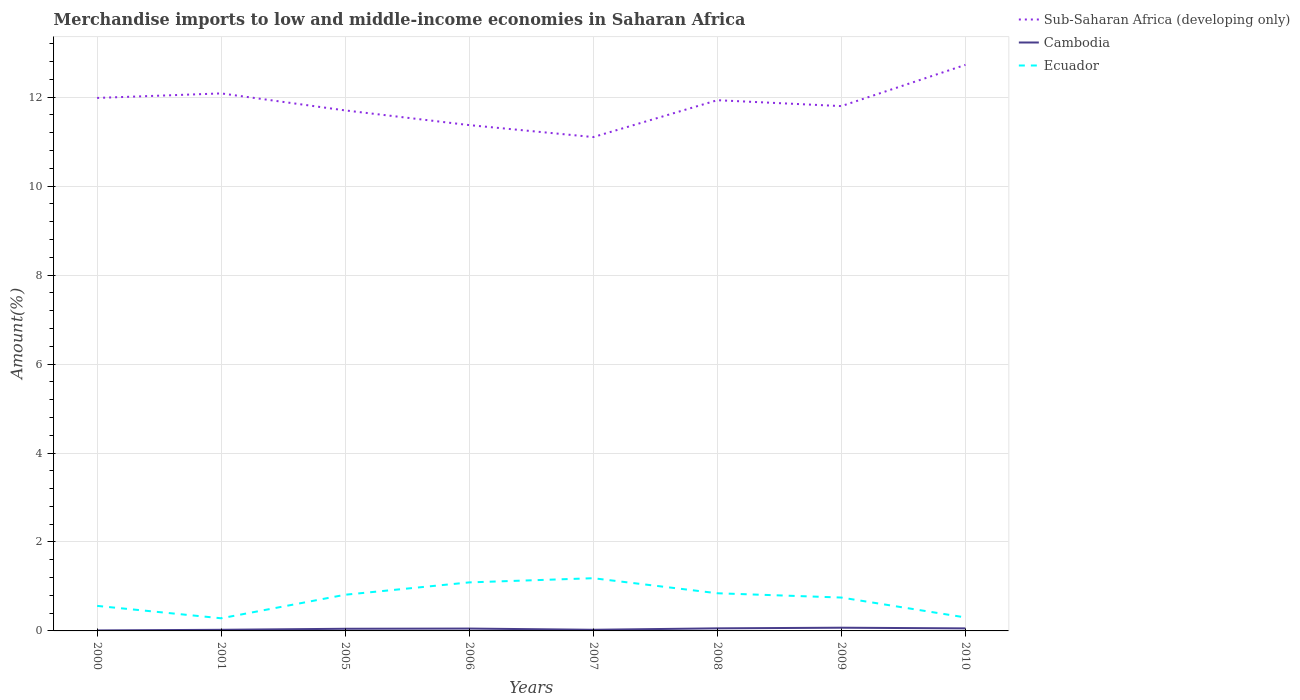Is the number of lines equal to the number of legend labels?
Provide a succinct answer. Yes. Across all years, what is the maximum percentage of amount earned from merchandise imports in Cambodia?
Offer a terse response. 0.01. In which year was the percentage of amount earned from merchandise imports in Cambodia maximum?
Ensure brevity in your answer.  2000. What is the total percentage of amount earned from merchandise imports in Cambodia in the graph?
Provide a succinct answer. -0.01. What is the difference between the highest and the second highest percentage of amount earned from merchandise imports in Sub-Saharan Africa (developing only)?
Keep it short and to the point. 1.62. Is the percentage of amount earned from merchandise imports in Sub-Saharan Africa (developing only) strictly greater than the percentage of amount earned from merchandise imports in Ecuador over the years?
Offer a terse response. No. What is the difference between two consecutive major ticks on the Y-axis?
Your answer should be very brief. 2. Are the values on the major ticks of Y-axis written in scientific E-notation?
Provide a short and direct response. No. Does the graph contain grids?
Ensure brevity in your answer.  Yes. How are the legend labels stacked?
Provide a succinct answer. Vertical. What is the title of the graph?
Offer a very short reply. Merchandise imports to low and middle-income economies in Saharan Africa. What is the label or title of the Y-axis?
Give a very brief answer. Amount(%). What is the Amount(%) in Sub-Saharan Africa (developing only) in 2000?
Your answer should be compact. 11.98. What is the Amount(%) of Cambodia in 2000?
Offer a very short reply. 0.01. What is the Amount(%) in Ecuador in 2000?
Your response must be concise. 0.56. What is the Amount(%) in Sub-Saharan Africa (developing only) in 2001?
Your answer should be very brief. 12.08. What is the Amount(%) of Cambodia in 2001?
Keep it short and to the point. 0.03. What is the Amount(%) in Ecuador in 2001?
Make the answer very short. 0.28. What is the Amount(%) of Sub-Saharan Africa (developing only) in 2005?
Make the answer very short. 11.7. What is the Amount(%) in Cambodia in 2005?
Offer a terse response. 0.05. What is the Amount(%) in Ecuador in 2005?
Give a very brief answer. 0.81. What is the Amount(%) in Sub-Saharan Africa (developing only) in 2006?
Make the answer very short. 11.37. What is the Amount(%) in Cambodia in 2006?
Provide a short and direct response. 0.05. What is the Amount(%) of Ecuador in 2006?
Your answer should be very brief. 1.09. What is the Amount(%) of Sub-Saharan Africa (developing only) in 2007?
Offer a very short reply. 11.1. What is the Amount(%) in Cambodia in 2007?
Keep it short and to the point. 0.03. What is the Amount(%) of Ecuador in 2007?
Your response must be concise. 1.19. What is the Amount(%) of Sub-Saharan Africa (developing only) in 2008?
Your answer should be compact. 11.93. What is the Amount(%) of Cambodia in 2008?
Make the answer very short. 0.06. What is the Amount(%) of Ecuador in 2008?
Keep it short and to the point. 0.85. What is the Amount(%) of Sub-Saharan Africa (developing only) in 2009?
Provide a short and direct response. 11.8. What is the Amount(%) of Cambodia in 2009?
Keep it short and to the point. 0.07. What is the Amount(%) in Ecuador in 2009?
Provide a short and direct response. 0.75. What is the Amount(%) in Sub-Saharan Africa (developing only) in 2010?
Make the answer very short. 12.73. What is the Amount(%) in Cambodia in 2010?
Offer a terse response. 0.06. What is the Amount(%) of Ecuador in 2010?
Keep it short and to the point. 0.3. Across all years, what is the maximum Amount(%) in Sub-Saharan Africa (developing only)?
Your answer should be compact. 12.73. Across all years, what is the maximum Amount(%) of Cambodia?
Make the answer very short. 0.07. Across all years, what is the maximum Amount(%) in Ecuador?
Give a very brief answer. 1.19. Across all years, what is the minimum Amount(%) of Sub-Saharan Africa (developing only)?
Give a very brief answer. 11.1. Across all years, what is the minimum Amount(%) of Cambodia?
Your answer should be compact. 0.01. Across all years, what is the minimum Amount(%) in Ecuador?
Your answer should be very brief. 0.28. What is the total Amount(%) in Sub-Saharan Africa (developing only) in the graph?
Ensure brevity in your answer.  94.7. What is the total Amount(%) in Cambodia in the graph?
Ensure brevity in your answer.  0.35. What is the total Amount(%) in Ecuador in the graph?
Offer a very short reply. 5.84. What is the difference between the Amount(%) of Sub-Saharan Africa (developing only) in 2000 and that in 2001?
Offer a terse response. -0.1. What is the difference between the Amount(%) in Cambodia in 2000 and that in 2001?
Give a very brief answer. -0.01. What is the difference between the Amount(%) in Ecuador in 2000 and that in 2001?
Provide a short and direct response. 0.28. What is the difference between the Amount(%) of Sub-Saharan Africa (developing only) in 2000 and that in 2005?
Your answer should be very brief. 0.28. What is the difference between the Amount(%) of Cambodia in 2000 and that in 2005?
Make the answer very short. -0.04. What is the difference between the Amount(%) of Ecuador in 2000 and that in 2005?
Keep it short and to the point. -0.25. What is the difference between the Amount(%) in Sub-Saharan Africa (developing only) in 2000 and that in 2006?
Provide a short and direct response. 0.61. What is the difference between the Amount(%) in Cambodia in 2000 and that in 2006?
Give a very brief answer. -0.04. What is the difference between the Amount(%) of Ecuador in 2000 and that in 2006?
Keep it short and to the point. -0.53. What is the difference between the Amount(%) in Sub-Saharan Africa (developing only) in 2000 and that in 2007?
Provide a succinct answer. 0.88. What is the difference between the Amount(%) of Cambodia in 2000 and that in 2007?
Keep it short and to the point. -0.01. What is the difference between the Amount(%) of Ecuador in 2000 and that in 2007?
Keep it short and to the point. -0.62. What is the difference between the Amount(%) in Sub-Saharan Africa (developing only) in 2000 and that in 2008?
Provide a short and direct response. 0.05. What is the difference between the Amount(%) in Cambodia in 2000 and that in 2008?
Offer a very short reply. -0.05. What is the difference between the Amount(%) in Ecuador in 2000 and that in 2008?
Your answer should be compact. -0.28. What is the difference between the Amount(%) in Sub-Saharan Africa (developing only) in 2000 and that in 2009?
Your answer should be very brief. 0.18. What is the difference between the Amount(%) of Cambodia in 2000 and that in 2009?
Provide a short and direct response. -0.06. What is the difference between the Amount(%) in Ecuador in 2000 and that in 2009?
Offer a very short reply. -0.19. What is the difference between the Amount(%) in Sub-Saharan Africa (developing only) in 2000 and that in 2010?
Ensure brevity in your answer.  -0.74. What is the difference between the Amount(%) in Cambodia in 2000 and that in 2010?
Keep it short and to the point. -0.05. What is the difference between the Amount(%) of Ecuador in 2000 and that in 2010?
Offer a very short reply. 0.26. What is the difference between the Amount(%) of Sub-Saharan Africa (developing only) in 2001 and that in 2005?
Provide a short and direct response. 0.38. What is the difference between the Amount(%) of Cambodia in 2001 and that in 2005?
Ensure brevity in your answer.  -0.02. What is the difference between the Amount(%) of Ecuador in 2001 and that in 2005?
Your response must be concise. -0.53. What is the difference between the Amount(%) in Sub-Saharan Africa (developing only) in 2001 and that in 2006?
Your answer should be compact. 0.71. What is the difference between the Amount(%) of Cambodia in 2001 and that in 2006?
Offer a terse response. -0.03. What is the difference between the Amount(%) in Ecuador in 2001 and that in 2006?
Your response must be concise. -0.81. What is the difference between the Amount(%) in Sub-Saharan Africa (developing only) in 2001 and that in 2007?
Give a very brief answer. 0.98. What is the difference between the Amount(%) in Cambodia in 2001 and that in 2007?
Your answer should be compact. -0. What is the difference between the Amount(%) of Ecuador in 2001 and that in 2007?
Your answer should be very brief. -0.9. What is the difference between the Amount(%) in Sub-Saharan Africa (developing only) in 2001 and that in 2008?
Your answer should be very brief. 0.15. What is the difference between the Amount(%) in Cambodia in 2001 and that in 2008?
Provide a short and direct response. -0.03. What is the difference between the Amount(%) in Ecuador in 2001 and that in 2008?
Your response must be concise. -0.56. What is the difference between the Amount(%) of Sub-Saharan Africa (developing only) in 2001 and that in 2009?
Give a very brief answer. 0.29. What is the difference between the Amount(%) of Cambodia in 2001 and that in 2009?
Give a very brief answer. -0.05. What is the difference between the Amount(%) of Ecuador in 2001 and that in 2009?
Offer a terse response. -0.47. What is the difference between the Amount(%) in Sub-Saharan Africa (developing only) in 2001 and that in 2010?
Provide a short and direct response. -0.64. What is the difference between the Amount(%) of Cambodia in 2001 and that in 2010?
Keep it short and to the point. -0.03. What is the difference between the Amount(%) in Ecuador in 2001 and that in 2010?
Your response must be concise. -0.02. What is the difference between the Amount(%) in Sub-Saharan Africa (developing only) in 2005 and that in 2006?
Your answer should be compact. 0.33. What is the difference between the Amount(%) of Cambodia in 2005 and that in 2006?
Provide a succinct answer. -0. What is the difference between the Amount(%) of Ecuador in 2005 and that in 2006?
Keep it short and to the point. -0.28. What is the difference between the Amount(%) in Sub-Saharan Africa (developing only) in 2005 and that in 2007?
Provide a succinct answer. 0.6. What is the difference between the Amount(%) in Cambodia in 2005 and that in 2007?
Give a very brief answer. 0.02. What is the difference between the Amount(%) of Ecuador in 2005 and that in 2007?
Offer a terse response. -0.37. What is the difference between the Amount(%) of Sub-Saharan Africa (developing only) in 2005 and that in 2008?
Your response must be concise. -0.23. What is the difference between the Amount(%) in Cambodia in 2005 and that in 2008?
Ensure brevity in your answer.  -0.01. What is the difference between the Amount(%) of Ecuador in 2005 and that in 2008?
Offer a very short reply. -0.03. What is the difference between the Amount(%) in Sub-Saharan Africa (developing only) in 2005 and that in 2009?
Offer a very short reply. -0.1. What is the difference between the Amount(%) in Cambodia in 2005 and that in 2009?
Your response must be concise. -0.02. What is the difference between the Amount(%) in Ecuador in 2005 and that in 2009?
Provide a succinct answer. 0.06. What is the difference between the Amount(%) of Sub-Saharan Africa (developing only) in 2005 and that in 2010?
Provide a succinct answer. -1.02. What is the difference between the Amount(%) of Cambodia in 2005 and that in 2010?
Your answer should be compact. -0.01. What is the difference between the Amount(%) in Ecuador in 2005 and that in 2010?
Your response must be concise. 0.51. What is the difference between the Amount(%) in Sub-Saharan Africa (developing only) in 2006 and that in 2007?
Give a very brief answer. 0.27. What is the difference between the Amount(%) of Cambodia in 2006 and that in 2007?
Give a very brief answer. 0.03. What is the difference between the Amount(%) of Ecuador in 2006 and that in 2007?
Keep it short and to the point. -0.09. What is the difference between the Amount(%) in Sub-Saharan Africa (developing only) in 2006 and that in 2008?
Your response must be concise. -0.56. What is the difference between the Amount(%) of Cambodia in 2006 and that in 2008?
Offer a very short reply. -0. What is the difference between the Amount(%) in Ecuador in 2006 and that in 2008?
Your answer should be very brief. 0.24. What is the difference between the Amount(%) of Sub-Saharan Africa (developing only) in 2006 and that in 2009?
Your response must be concise. -0.43. What is the difference between the Amount(%) of Cambodia in 2006 and that in 2009?
Offer a very short reply. -0.02. What is the difference between the Amount(%) of Ecuador in 2006 and that in 2009?
Your answer should be very brief. 0.34. What is the difference between the Amount(%) in Sub-Saharan Africa (developing only) in 2006 and that in 2010?
Offer a terse response. -1.35. What is the difference between the Amount(%) of Cambodia in 2006 and that in 2010?
Provide a succinct answer. -0. What is the difference between the Amount(%) in Ecuador in 2006 and that in 2010?
Offer a terse response. 0.79. What is the difference between the Amount(%) in Sub-Saharan Africa (developing only) in 2007 and that in 2008?
Make the answer very short. -0.83. What is the difference between the Amount(%) in Cambodia in 2007 and that in 2008?
Make the answer very short. -0.03. What is the difference between the Amount(%) in Ecuador in 2007 and that in 2008?
Provide a short and direct response. 0.34. What is the difference between the Amount(%) of Sub-Saharan Africa (developing only) in 2007 and that in 2009?
Your answer should be very brief. -0.7. What is the difference between the Amount(%) of Cambodia in 2007 and that in 2009?
Your answer should be compact. -0.05. What is the difference between the Amount(%) in Ecuador in 2007 and that in 2009?
Keep it short and to the point. 0.43. What is the difference between the Amount(%) in Sub-Saharan Africa (developing only) in 2007 and that in 2010?
Offer a terse response. -1.62. What is the difference between the Amount(%) of Cambodia in 2007 and that in 2010?
Offer a very short reply. -0.03. What is the difference between the Amount(%) in Ecuador in 2007 and that in 2010?
Provide a succinct answer. 0.88. What is the difference between the Amount(%) in Sub-Saharan Africa (developing only) in 2008 and that in 2009?
Ensure brevity in your answer.  0.13. What is the difference between the Amount(%) in Cambodia in 2008 and that in 2009?
Give a very brief answer. -0.01. What is the difference between the Amount(%) in Ecuador in 2008 and that in 2009?
Give a very brief answer. 0.1. What is the difference between the Amount(%) of Sub-Saharan Africa (developing only) in 2008 and that in 2010?
Provide a succinct answer. -0.79. What is the difference between the Amount(%) of Cambodia in 2008 and that in 2010?
Your response must be concise. 0. What is the difference between the Amount(%) of Ecuador in 2008 and that in 2010?
Offer a terse response. 0.54. What is the difference between the Amount(%) of Sub-Saharan Africa (developing only) in 2009 and that in 2010?
Your answer should be very brief. -0.93. What is the difference between the Amount(%) of Cambodia in 2009 and that in 2010?
Provide a succinct answer. 0.02. What is the difference between the Amount(%) in Ecuador in 2009 and that in 2010?
Your response must be concise. 0.45. What is the difference between the Amount(%) in Sub-Saharan Africa (developing only) in 2000 and the Amount(%) in Cambodia in 2001?
Make the answer very short. 11.96. What is the difference between the Amount(%) in Sub-Saharan Africa (developing only) in 2000 and the Amount(%) in Ecuador in 2001?
Your answer should be very brief. 11.7. What is the difference between the Amount(%) in Cambodia in 2000 and the Amount(%) in Ecuador in 2001?
Offer a terse response. -0.27. What is the difference between the Amount(%) of Sub-Saharan Africa (developing only) in 2000 and the Amount(%) of Cambodia in 2005?
Offer a terse response. 11.93. What is the difference between the Amount(%) of Sub-Saharan Africa (developing only) in 2000 and the Amount(%) of Ecuador in 2005?
Provide a short and direct response. 11.17. What is the difference between the Amount(%) in Cambodia in 2000 and the Amount(%) in Ecuador in 2005?
Provide a short and direct response. -0.8. What is the difference between the Amount(%) in Sub-Saharan Africa (developing only) in 2000 and the Amount(%) in Cambodia in 2006?
Ensure brevity in your answer.  11.93. What is the difference between the Amount(%) of Sub-Saharan Africa (developing only) in 2000 and the Amount(%) of Ecuador in 2006?
Keep it short and to the point. 10.89. What is the difference between the Amount(%) of Cambodia in 2000 and the Amount(%) of Ecuador in 2006?
Your answer should be compact. -1.08. What is the difference between the Amount(%) in Sub-Saharan Africa (developing only) in 2000 and the Amount(%) in Cambodia in 2007?
Provide a short and direct response. 11.96. What is the difference between the Amount(%) in Sub-Saharan Africa (developing only) in 2000 and the Amount(%) in Ecuador in 2007?
Give a very brief answer. 10.8. What is the difference between the Amount(%) of Cambodia in 2000 and the Amount(%) of Ecuador in 2007?
Provide a short and direct response. -1.17. What is the difference between the Amount(%) in Sub-Saharan Africa (developing only) in 2000 and the Amount(%) in Cambodia in 2008?
Give a very brief answer. 11.92. What is the difference between the Amount(%) of Sub-Saharan Africa (developing only) in 2000 and the Amount(%) of Ecuador in 2008?
Provide a short and direct response. 11.14. What is the difference between the Amount(%) of Cambodia in 2000 and the Amount(%) of Ecuador in 2008?
Your response must be concise. -0.84. What is the difference between the Amount(%) of Sub-Saharan Africa (developing only) in 2000 and the Amount(%) of Cambodia in 2009?
Keep it short and to the point. 11.91. What is the difference between the Amount(%) of Sub-Saharan Africa (developing only) in 2000 and the Amount(%) of Ecuador in 2009?
Make the answer very short. 11.23. What is the difference between the Amount(%) of Cambodia in 2000 and the Amount(%) of Ecuador in 2009?
Offer a very short reply. -0.74. What is the difference between the Amount(%) of Sub-Saharan Africa (developing only) in 2000 and the Amount(%) of Cambodia in 2010?
Your response must be concise. 11.93. What is the difference between the Amount(%) in Sub-Saharan Africa (developing only) in 2000 and the Amount(%) in Ecuador in 2010?
Your answer should be compact. 11.68. What is the difference between the Amount(%) in Cambodia in 2000 and the Amount(%) in Ecuador in 2010?
Make the answer very short. -0.29. What is the difference between the Amount(%) of Sub-Saharan Africa (developing only) in 2001 and the Amount(%) of Cambodia in 2005?
Your answer should be very brief. 12.04. What is the difference between the Amount(%) in Sub-Saharan Africa (developing only) in 2001 and the Amount(%) in Ecuador in 2005?
Ensure brevity in your answer.  11.27. What is the difference between the Amount(%) in Cambodia in 2001 and the Amount(%) in Ecuador in 2005?
Ensure brevity in your answer.  -0.79. What is the difference between the Amount(%) in Sub-Saharan Africa (developing only) in 2001 and the Amount(%) in Cambodia in 2006?
Ensure brevity in your answer.  12.03. What is the difference between the Amount(%) of Sub-Saharan Africa (developing only) in 2001 and the Amount(%) of Ecuador in 2006?
Your response must be concise. 10.99. What is the difference between the Amount(%) of Cambodia in 2001 and the Amount(%) of Ecuador in 2006?
Your answer should be compact. -1.07. What is the difference between the Amount(%) in Sub-Saharan Africa (developing only) in 2001 and the Amount(%) in Cambodia in 2007?
Offer a terse response. 12.06. What is the difference between the Amount(%) of Sub-Saharan Africa (developing only) in 2001 and the Amount(%) of Ecuador in 2007?
Your answer should be compact. 10.9. What is the difference between the Amount(%) in Cambodia in 2001 and the Amount(%) in Ecuador in 2007?
Your answer should be very brief. -1.16. What is the difference between the Amount(%) of Sub-Saharan Africa (developing only) in 2001 and the Amount(%) of Cambodia in 2008?
Your response must be concise. 12.03. What is the difference between the Amount(%) of Sub-Saharan Africa (developing only) in 2001 and the Amount(%) of Ecuador in 2008?
Offer a terse response. 11.24. What is the difference between the Amount(%) in Cambodia in 2001 and the Amount(%) in Ecuador in 2008?
Your answer should be very brief. -0.82. What is the difference between the Amount(%) in Sub-Saharan Africa (developing only) in 2001 and the Amount(%) in Cambodia in 2009?
Give a very brief answer. 12.01. What is the difference between the Amount(%) of Sub-Saharan Africa (developing only) in 2001 and the Amount(%) of Ecuador in 2009?
Your answer should be very brief. 11.33. What is the difference between the Amount(%) in Cambodia in 2001 and the Amount(%) in Ecuador in 2009?
Keep it short and to the point. -0.73. What is the difference between the Amount(%) of Sub-Saharan Africa (developing only) in 2001 and the Amount(%) of Cambodia in 2010?
Offer a terse response. 12.03. What is the difference between the Amount(%) in Sub-Saharan Africa (developing only) in 2001 and the Amount(%) in Ecuador in 2010?
Keep it short and to the point. 11.78. What is the difference between the Amount(%) of Cambodia in 2001 and the Amount(%) of Ecuador in 2010?
Your answer should be very brief. -0.28. What is the difference between the Amount(%) in Sub-Saharan Africa (developing only) in 2005 and the Amount(%) in Cambodia in 2006?
Provide a short and direct response. 11.65. What is the difference between the Amount(%) of Sub-Saharan Africa (developing only) in 2005 and the Amount(%) of Ecuador in 2006?
Keep it short and to the point. 10.61. What is the difference between the Amount(%) in Cambodia in 2005 and the Amount(%) in Ecuador in 2006?
Your response must be concise. -1.04. What is the difference between the Amount(%) in Sub-Saharan Africa (developing only) in 2005 and the Amount(%) in Cambodia in 2007?
Your answer should be very brief. 11.68. What is the difference between the Amount(%) in Sub-Saharan Africa (developing only) in 2005 and the Amount(%) in Ecuador in 2007?
Provide a succinct answer. 10.52. What is the difference between the Amount(%) of Cambodia in 2005 and the Amount(%) of Ecuador in 2007?
Offer a very short reply. -1.14. What is the difference between the Amount(%) in Sub-Saharan Africa (developing only) in 2005 and the Amount(%) in Cambodia in 2008?
Offer a terse response. 11.64. What is the difference between the Amount(%) in Sub-Saharan Africa (developing only) in 2005 and the Amount(%) in Ecuador in 2008?
Provide a succinct answer. 10.86. What is the difference between the Amount(%) of Cambodia in 2005 and the Amount(%) of Ecuador in 2008?
Provide a short and direct response. -0.8. What is the difference between the Amount(%) in Sub-Saharan Africa (developing only) in 2005 and the Amount(%) in Cambodia in 2009?
Give a very brief answer. 11.63. What is the difference between the Amount(%) of Sub-Saharan Africa (developing only) in 2005 and the Amount(%) of Ecuador in 2009?
Your answer should be compact. 10.95. What is the difference between the Amount(%) of Cambodia in 2005 and the Amount(%) of Ecuador in 2009?
Offer a terse response. -0.7. What is the difference between the Amount(%) in Sub-Saharan Africa (developing only) in 2005 and the Amount(%) in Cambodia in 2010?
Your answer should be compact. 11.65. What is the difference between the Amount(%) in Sub-Saharan Africa (developing only) in 2005 and the Amount(%) in Ecuador in 2010?
Ensure brevity in your answer.  11.4. What is the difference between the Amount(%) in Cambodia in 2005 and the Amount(%) in Ecuador in 2010?
Ensure brevity in your answer.  -0.25. What is the difference between the Amount(%) of Sub-Saharan Africa (developing only) in 2006 and the Amount(%) of Cambodia in 2007?
Ensure brevity in your answer.  11.35. What is the difference between the Amount(%) in Sub-Saharan Africa (developing only) in 2006 and the Amount(%) in Ecuador in 2007?
Your answer should be very brief. 10.19. What is the difference between the Amount(%) of Cambodia in 2006 and the Amount(%) of Ecuador in 2007?
Make the answer very short. -1.13. What is the difference between the Amount(%) of Sub-Saharan Africa (developing only) in 2006 and the Amount(%) of Cambodia in 2008?
Make the answer very short. 11.31. What is the difference between the Amount(%) of Sub-Saharan Africa (developing only) in 2006 and the Amount(%) of Ecuador in 2008?
Make the answer very short. 10.53. What is the difference between the Amount(%) of Cambodia in 2006 and the Amount(%) of Ecuador in 2008?
Offer a terse response. -0.79. What is the difference between the Amount(%) in Sub-Saharan Africa (developing only) in 2006 and the Amount(%) in Cambodia in 2009?
Keep it short and to the point. 11.3. What is the difference between the Amount(%) of Sub-Saharan Africa (developing only) in 2006 and the Amount(%) of Ecuador in 2009?
Your answer should be very brief. 10.62. What is the difference between the Amount(%) of Cambodia in 2006 and the Amount(%) of Ecuador in 2009?
Keep it short and to the point. -0.7. What is the difference between the Amount(%) of Sub-Saharan Africa (developing only) in 2006 and the Amount(%) of Cambodia in 2010?
Your answer should be compact. 11.32. What is the difference between the Amount(%) in Sub-Saharan Africa (developing only) in 2006 and the Amount(%) in Ecuador in 2010?
Make the answer very short. 11.07. What is the difference between the Amount(%) of Cambodia in 2006 and the Amount(%) of Ecuador in 2010?
Provide a succinct answer. -0.25. What is the difference between the Amount(%) of Sub-Saharan Africa (developing only) in 2007 and the Amount(%) of Cambodia in 2008?
Your answer should be compact. 11.05. What is the difference between the Amount(%) of Sub-Saharan Africa (developing only) in 2007 and the Amount(%) of Ecuador in 2008?
Offer a very short reply. 10.26. What is the difference between the Amount(%) in Cambodia in 2007 and the Amount(%) in Ecuador in 2008?
Provide a short and direct response. -0.82. What is the difference between the Amount(%) of Sub-Saharan Africa (developing only) in 2007 and the Amount(%) of Cambodia in 2009?
Make the answer very short. 11.03. What is the difference between the Amount(%) in Sub-Saharan Africa (developing only) in 2007 and the Amount(%) in Ecuador in 2009?
Keep it short and to the point. 10.35. What is the difference between the Amount(%) of Cambodia in 2007 and the Amount(%) of Ecuador in 2009?
Offer a terse response. -0.72. What is the difference between the Amount(%) of Sub-Saharan Africa (developing only) in 2007 and the Amount(%) of Cambodia in 2010?
Keep it short and to the point. 11.05. What is the difference between the Amount(%) in Sub-Saharan Africa (developing only) in 2007 and the Amount(%) in Ecuador in 2010?
Your response must be concise. 10.8. What is the difference between the Amount(%) in Cambodia in 2007 and the Amount(%) in Ecuador in 2010?
Your answer should be very brief. -0.28. What is the difference between the Amount(%) in Sub-Saharan Africa (developing only) in 2008 and the Amount(%) in Cambodia in 2009?
Offer a terse response. 11.86. What is the difference between the Amount(%) in Sub-Saharan Africa (developing only) in 2008 and the Amount(%) in Ecuador in 2009?
Provide a short and direct response. 11.18. What is the difference between the Amount(%) of Cambodia in 2008 and the Amount(%) of Ecuador in 2009?
Your answer should be very brief. -0.69. What is the difference between the Amount(%) of Sub-Saharan Africa (developing only) in 2008 and the Amount(%) of Cambodia in 2010?
Provide a short and direct response. 11.88. What is the difference between the Amount(%) in Sub-Saharan Africa (developing only) in 2008 and the Amount(%) in Ecuador in 2010?
Your response must be concise. 11.63. What is the difference between the Amount(%) in Cambodia in 2008 and the Amount(%) in Ecuador in 2010?
Give a very brief answer. -0.24. What is the difference between the Amount(%) in Sub-Saharan Africa (developing only) in 2009 and the Amount(%) in Cambodia in 2010?
Provide a succinct answer. 11.74. What is the difference between the Amount(%) of Sub-Saharan Africa (developing only) in 2009 and the Amount(%) of Ecuador in 2010?
Give a very brief answer. 11.5. What is the difference between the Amount(%) in Cambodia in 2009 and the Amount(%) in Ecuador in 2010?
Keep it short and to the point. -0.23. What is the average Amount(%) in Sub-Saharan Africa (developing only) per year?
Your answer should be very brief. 11.84. What is the average Amount(%) of Cambodia per year?
Provide a succinct answer. 0.04. What is the average Amount(%) of Ecuador per year?
Ensure brevity in your answer.  0.73. In the year 2000, what is the difference between the Amount(%) in Sub-Saharan Africa (developing only) and Amount(%) in Cambodia?
Keep it short and to the point. 11.97. In the year 2000, what is the difference between the Amount(%) of Sub-Saharan Africa (developing only) and Amount(%) of Ecuador?
Keep it short and to the point. 11.42. In the year 2000, what is the difference between the Amount(%) of Cambodia and Amount(%) of Ecuador?
Offer a terse response. -0.55. In the year 2001, what is the difference between the Amount(%) of Sub-Saharan Africa (developing only) and Amount(%) of Cambodia?
Your answer should be compact. 12.06. In the year 2001, what is the difference between the Amount(%) in Sub-Saharan Africa (developing only) and Amount(%) in Ecuador?
Offer a terse response. 11.8. In the year 2001, what is the difference between the Amount(%) of Cambodia and Amount(%) of Ecuador?
Make the answer very short. -0.26. In the year 2005, what is the difference between the Amount(%) of Sub-Saharan Africa (developing only) and Amount(%) of Cambodia?
Give a very brief answer. 11.65. In the year 2005, what is the difference between the Amount(%) in Sub-Saharan Africa (developing only) and Amount(%) in Ecuador?
Provide a succinct answer. 10.89. In the year 2005, what is the difference between the Amount(%) of Cambodia and Amount(%) of Ecuador?
Your answer should be compact. -0.77. In the year 2006, what is the difference between the Amount(%) in Sub-Saharan Africa (developing only) and Amount(%) in Cambodia?
Provide a short and direct response. 11.32. In the year 2006, what is the difference between the Amount(%) of Sub-Saharan Africa (developing only) and Amount(%) of Ecuador?
Your response must be concise. 10.28. In the year 2006, what is the difference between the Amount(%) of Cambodia and Amount(%) of Ecuador?
Your response must be concise. -1.04. In the year 2007, what is the difference between the Amount(%) in Sub-Saharan Africa (developing only) and Amount(%) in Cambodia?
Provide a succinct answer. 11.08. In the year 2007, what is the difference between the Amount(%) of Sub-Saharan Africa (developing only) and Amount(%) of Ecuador?
Ensure brevity in your answer.  9.92. In the year 2007, what is the difference between the Amount(%) in Cambodia and Amount(%) in Ecuador?
Provide a succinct answer. -1.16. In the year 2008, what is the difference between the Amount(%) in Sub-Saharan Africa (developing only) and Amount(%) in Cambodia?
Ensure brevity in your answer.  11.87. In the year 2008, what is the difference between the Amount(%) in Sub-Saharan Africa (developing only) and Amount(%) in Ecuador?
Your answer should be compact. 11.09. In the year 2008, what is the difference between the Amount(%) in Cambodia and Amount(%) in Ecuador?
Keep it short and to the point. -0.79. In the year 2009, what is the difference between the Amount(%) in Sub-Saharan Africa (developing only) and Amount(%) in Cambodia?
Provide a succinct answer. 11.73. In the year 2009, what is the difference between the Amount(%) in Sub-Saharan Africa (developing only) and Amount(%) in Ecuador?
Offer a terse response. 11.05. In the year 2009, what is the difference between the Amount(%) of Cambodia and Amount(%) of Ecuador?
Provide a short and direct response. -0.68. In the year 2010, what is the difference between the Amount(%) in Sub-Saharan Africa (developing only) and Amount(%) in Cambodia?
Give a very brief answer. 12.67. In the year 2010, what is the difference between the Amount(%) in Sub-Saharan Africa (developing only) and Amount(%) in Ecuador?
Make the answer very short. 12.42. In the year 2010, what is the difference between the Amount(%) of Cambodia and Amount(%) of Ecuador?
Your response must be concise. -0.25. What is the ratio of the Amount(%) of Sub-Saharan Africa (developing only) in 2000 to that in 2001?
Your answer should be very brief. 0.99. What is the ratio of the Amount(%) of Cambodia in 2000 to that in 2001?
Offer a terse response. 0.45. What is the ratio of the Amount(%) in Ecuador in 2000 to that in 2001?
Give a very brief answer. 1.98. What is the ratio of the Amount(%) in Sub-Saharan Africa (developing only) in 2000 to that in 2005?
Your answer should be very brief. 1.02. What is the ratio of the Amount(%) in Cambodia in 2000 to that in 2005?
Give a very brief answer. 0.23. What is the ratio of the Amount(%) in Ecuador in 2000 to that in 2005?
Make the answer very short. 0.69. What is the ratio of the Amount(%) in Sub-Saharan Africa (developing only) in 2000 to that in 2006?
Your answer should be compact. 1.05. What is the ratio of the Amount(%) in Cambodia in 2000 to that in 2006?
Provide a short and direct response. 0.21. What is the ratio of the Amount(%) in Ecuador in 2000 to that in 2006?
Make the answer very short. 0.52. What is the ratio of the Amount(%) in Sub-Saharan Africa (developing only) in 2000 to that in 2007?
Your response must be concise. 1.08. What is the ratio of the Amount(%) of Cambodia in 2000 to that in 2007?
Provide a succinct answer. 0.44. What is the ratio of the Amount(%) of Ecuador in 2000 to that in 2007?
Offer a terse response. 0.47. What is the ratio of the Amount(%) of Cambodia in 2000 to that in 2008?
Give a very brief answer. 0.2. What is the ratio of the Amount(%) in Ecuador in 2000 to that in 2008?
Your answer should be compact. 0.66. What is the ratio of the Amount(%) of Sub-Saharan Africa (developing only) in 2000 to that in 2009?
Your answer should be compact. 1.02. What is the ratio of the Amount(%) of Cambodia in 2000 to that in 2009?
Your response must be concise. 0.16. What is the ratio of the Amount(%) in Ecuador in 2000 to that in 2009?
Your answer should be compact. 0.75. What is the ratio of the Amount(%) in Sub-Saharan Africa (developing only) in 2000 to that in 2010?
Give a very brief answer. 0.94. What is the ratio of the Amount(%) in Cambodia in 2000 to that in 2010?
Make the answer very short. 0.2. What is the ratio of the Amount(%) of Ecuador in 2000 to that in 2010?
Make the answer very short. 1.86. What is the ratio of the Amount(%) of Sub-Saharan Africa (developing only) in 2001 to that in 2005?
Provide a succinct answer. 1.03. What is the ratio of the Amount(%) of Cambodia in 2001 to that in 2005?
Offer a terse response. 0.53. What is the ratio of the Amount(%) in Ecuador in 2001 to that in 2005?
Make the answer very short. 0.35. What is the ratio of the Amount(%) in Sub-Saharan Africa (developing only) in 2001 to that in 2006?
Provide a short and direct response. 1.06. What is the ratio of the Amount(%) in Cambodia in 2001 to that in 2006?
Keep it short and to the point. 0.48. What is the ratio of the Amount(%) of Ecuador in 2001 to that in 2006?
Your response must be concise. 0.26. What is the ratio of the Amount(%) of Sub-Saharan Africa (developing only) in 2001 to that in 2007?
Provide a succinct answer. 1.09. What is the ratio of the Amount(%) of Ecuador in 2001 to that in 2007?
Provide a short and direct response. 0.24. What is the ratio of the Amount(%) of Sub-Saharan Africa (developing only) in 2001 to that in 2008?
Your answer should be compact. 1.01. What is the ratio of the Amount(%) of Cambodia in 2001 to that in 2008?
Keep it short and to the point. 0.44. What is the ratio of the Amount(%) in Ecuador in 2001 to that in 2008?
Ensure brevity in your answer.  0.34. What is the ratio of the Amount(%) of Sub-Saharan Africa (developing only) in 2001 to that in 2009?
Give a very brief answer. 1.02. What is the ratio of the Amount(%) of Cambodia in 2001 to that in 2009?
Provide a short and direct response. 0.35. What is the ratio of the Amount(%) of Ecuador in 2001 to that in 2009?
Keep it short and to the point. 0.38. What is the ratio of the Amount(%) of Sub-Saharan Africa (developing only) in 2001 to that in 2010?
Give a very brief answer. 0.95. What is the ratio of the Amount(%) of Cambodia in 2001 to that in 2010?
Offer a terse response. 0.45. What is the ratio of the Amount(%) of Ecuador in 2001 to that in 2010?
Provide a succinct answer. 0.94. What is the ratio of the Amount(%) in Cambodia in 2005 to that in 2006?
Offer a terse response. 0.91. What is the ratio of the Amount(%) of Ecuador in 2005 to that in 2006?
Provide a short and direct response. 0.75. What is the ratio of the Amount(%) of Sub-Saharan Africa (developing only) in 2005 to that in 2007?
Keep it short and to the point. 1.05. What is the ratio of the Amount(%) in Cambodia in 2005 to that in 2007?
Your answer should be compact. 1.88. What is the ratio of the Amount(%) in Ecuador in 2005 to that in 2007?
Provide a succinct answer. 0.69. What is the ratio of the Amount(%) in Sub-Saharan Africa (developing only) in 2005 to that in 2008?
Offer a terse response. 0.98. What is the ratio of the Amount(%) of Cambodia in 2005 to that in 2008?
Give a very brief answer. 0.83. What is the ratio of the Amount(%) of Ecuador in 2005 to that in 2008?
Provide a short and direct response. 0.96. What is the ratio of the Amount(%) in Sub-Saharan Africa (developing only) in 2005 to that in 2009?
Make the answer very short. 0.99. What is the ratio of the Amount(%) of Cambodia in 2005 to that in 2009?
Make the answer very short. 0.67. What is the ratio of the Amount(%) of Ecuador in 2005 to that in 2009?
Provide a succinct answer. 1.08. What is the ratio of the Amount(%) in Sub-Saharan Africa (developing only) in 2005 to that in 2010?
Keep it short and to the point. 0.92. What is the ratio of the Amount(%) of Cambodia in 2005 to that in 2010?
Your response must be concise. 0.85. What is the ratio of the Amount(%) in Ecuador in 2005 to that in 2010?
Your answer should be compact. 2.69. What is the ratio of the Amount(%) in Sub-Saharan Africa (developing only) in 2006 to that in 2007?
Your response must be concise. 1.02. What is the ratio of the Amount(%) of Cambodia in 2006 to that in 2007?
Provide a short and direct response. 2.07. What is the ratio of the Amount(%) of Ecuador in 2006 to that in 2007?
Provide a succinct answer. 0.92. What is the ratio of the Amount(%) in Sub-Saharan Africa (developing only) in 2006 to that in 2008?
Provide a succinct answer. 0.95. What is the ratio of the Amount(%) in Cambodia in 2006 to that in 2008?
Make the answer very short. 0.92. What is the ratio of the Amount(%) of Ecuador in 2006 to that in 2008?
Provide a short and direct response. 1.29. What is the ratio of the Amount(%) of Sub-Saharan Africa (developing only) in 2006 to that in 2009?
Offer a terse response. 0.96. What is the ratio of the Amount(%) in Cambodia in 2006 to that in 2009?
Provide a short and direct response. 0.73. What is the ratio of the Amount(%) in Ecuador in 2006 to that in 2009?
Offer a very short reply. 1.45. What is the ratio of the Amount(%) of Sub-Saharan Africa (developing only) in 2006 to that in 2010?
Give a very brief answer. 0.89. What is the ratio of the Amount(%) of Cambodia in 2006 to that in 2010?
Make the answer very short. 0.93. What is the ratio of the Amount(%) of Ecuador in 2006 to that in 2010?
Give a very brief answer. 3.6. What is the ratio of the Amount(%) in Sub-Saharan Africa (developing only) in 2007 to that in 2008?
Keep it short and to the point. 0.93. What is the ratio of the Amount(%) of Cambodia in 2007 to that in 2008?
Make the answer very short. 0.44. What is the ratio of the Amount(%) in Ecuador in 2007 to that in 2008?
Make the answer very short. 1.4. What is the ratio of the Amount(%) of Sub-Saharan Africa (developing only) in 2007 to that in 2009?
Offer a very short reply. 0.94. What is the ratio of the Amount(%) in Cambodia in 2007 to that in 2009?
Make the answer very short. 0.35. What is the ratio of the Amount(%) in Ecuador in 2007 to that in 2009?
Make the answer very short. 1.58. What is the ratio of the Amount(%) in Sub-Saharan Africa (developing only) in 2007 to that in 2010?
Your response must be concise. 0.87. What is the ratio of the Amount(%) in Cambodia in 2007 to that in 2010?
Make the answer very short. 0.45. What is the ratio of the Amount(%) in Ecuador in 2007 to that in 2010?
Keep it short and to the point. 3.91. What is the ratio of the Amount(%) of Sub-Saharan Africa (developing only) in 2008 to that in 2009?
Your answer should be very brief. 1.01. What is the ratio of the Amount(%) of Cambodia in 2008 to that in 2009?
Keep it short and to the point. 0.8. What is the ratio of the Amount(%) of Ecuador in 2008 to that in 2009?
Make the answer very short. 1.13. What is the ratio of the Amount(%) in Sub-Saharan Africa (developing only) in 2008 to that in 2010?
Make the answer very short. 0.94. What is the ratio of the Amount(%) in Cambodia in 2008 to that in 2010?
Your answer should be compact. 1.02. What is the ratio of the Amount(%) of Ecuador in 2008 to that in 2010?
Ensure brevity in your answer.  2.8. What is the ratio of the Amount(%) of Sub-Saharan Africa (developing only) in 2009 to that in 2010?
Make the answer very short. 0.93. What is the ratio of the Amount(%) of Cambodia in 2009 to that in 2010?
Offer a terse response. 1.27. What is the ratio of the Amount(%) in Ecuador in 2009 to that in 2010?
Your answer should be very brief. 2.48. What is the difference between the highest and the second highest Amount(%) in Sub-Saharan Africa (developing only)?
Keep it short and to the point. 0.64. What is the difference between the highest and the second highest Amount(%) in Cambodia?
Keep it short and to the point. 0.01. What is the difference between the highest and the second highest Amount(%) in Ecuador?
Your answer should be compact. 0.09. What is the difference between the highest and the lowest Amount(%) of Sub-Saharan Africa (developing only)?
Offer a terse response. 1.62. What is the difference between the highest and the lowest Amount(%) in Cambodia?
Keep it short and to the point. 0.06. What is the difference between the highest and the lowest Amount(%) in Ecuador?
Keep it short and to the point. 0.9. 